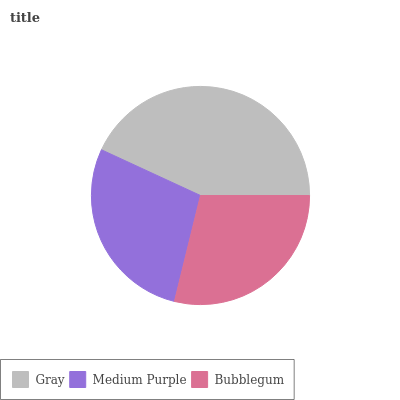Is Medium Purple the minimum?
Answer yes or no. Yes. Is Gray the maximum?
Answer yes or no. Yes. Is Bubblegum the minimum?
Answer yes or no. No. Is Bubblegum the maximum?
Answer yes or no. No. Is Bubblegum greater than Medium Purple?
Answer yes or no. Yes. Is Medium Purple less than Bubblegum?
Answer yes or no. Yes. Is Medium Purple greater than Bubblegum?
Answer yes or no. No. Is Bubblegum less than Medium Purple?
Answer yes or no. No. Is Bubblegum the high median?
Answer yes or no. Yes. Is Bubblegum the low median?
Answer yes or no. Yes. Is Medium Purple the high median?
Answer yes or no. No. Is Gray the low median?
Answer yes or no. No. 